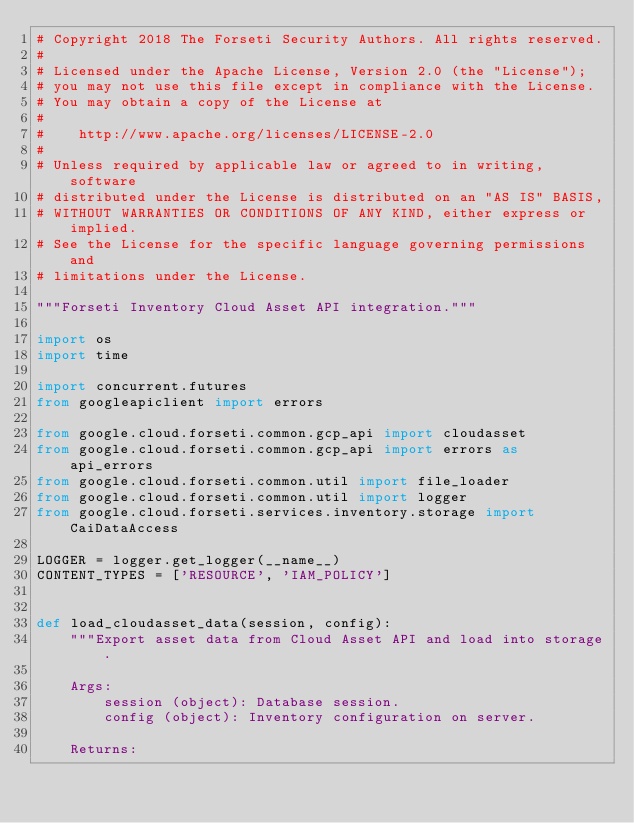<code> <loc_0><loc_0><loc_500><loc_500><_Python_># Copyright 2018 The Forseti Security Authors. All rights reserved.
#
# Licensed under the Apache License, Version 2.0 (the "License");
# you may not use this file except in compliance with the License.
# You may obtain a copy of the License at
#
#    http://www.apache.org/licenses/LICENSE-2.0
#
# Unless required by applicable law or agreed to in writing, software
# distributed under the License is distributed on an "AS IS" BASIS,
# WITHOUT WARRANTIES OR CONDITIONS OF ANY KIND, either express or implied.
# See the License for the specific language governing permissions and
# limitations under the License.

"""Forseti Inventory Cloud Asset API integration."""

import os
import time

import concurrent.futures
from googleapiclient import errors

from google.cloud.forseti.common.gcp_api import cloudasset
from google.cloud.forseti.common.gcp_api import errors as api_errors
from google.cloud.forseti.common.util import file_loader
from google.cloud.forseti.common.util import logger
from google.cloud.forseti.services.inventory.storage import CaiDataAccess

LOGGER = logger.get_logger(__name__)
CONTENT_TYPES = ['RESOURCE', 'IAM_POLICY']


def load_cloudasset_data(session, config):
    """Export asset data from Cloud Asset API and load into storage.

    Args:
        session (object): Database session.
        config (object): Inventory configuration on server.

    Returns:</code> 